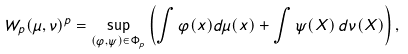Convert formula to latex. <formula><loc_0><loc_0><loc_500><loc_500>W _ { p } ( \mu , \nu ) ^ { p } = \sup _ { ( \varphi , \psi ) \in \Phi _ { p } } \left ( \int \varphi ( x ) d \mu ( x ) + \int \psi ( X ) \, d \nu ( X ) \right ) ,</formula> 